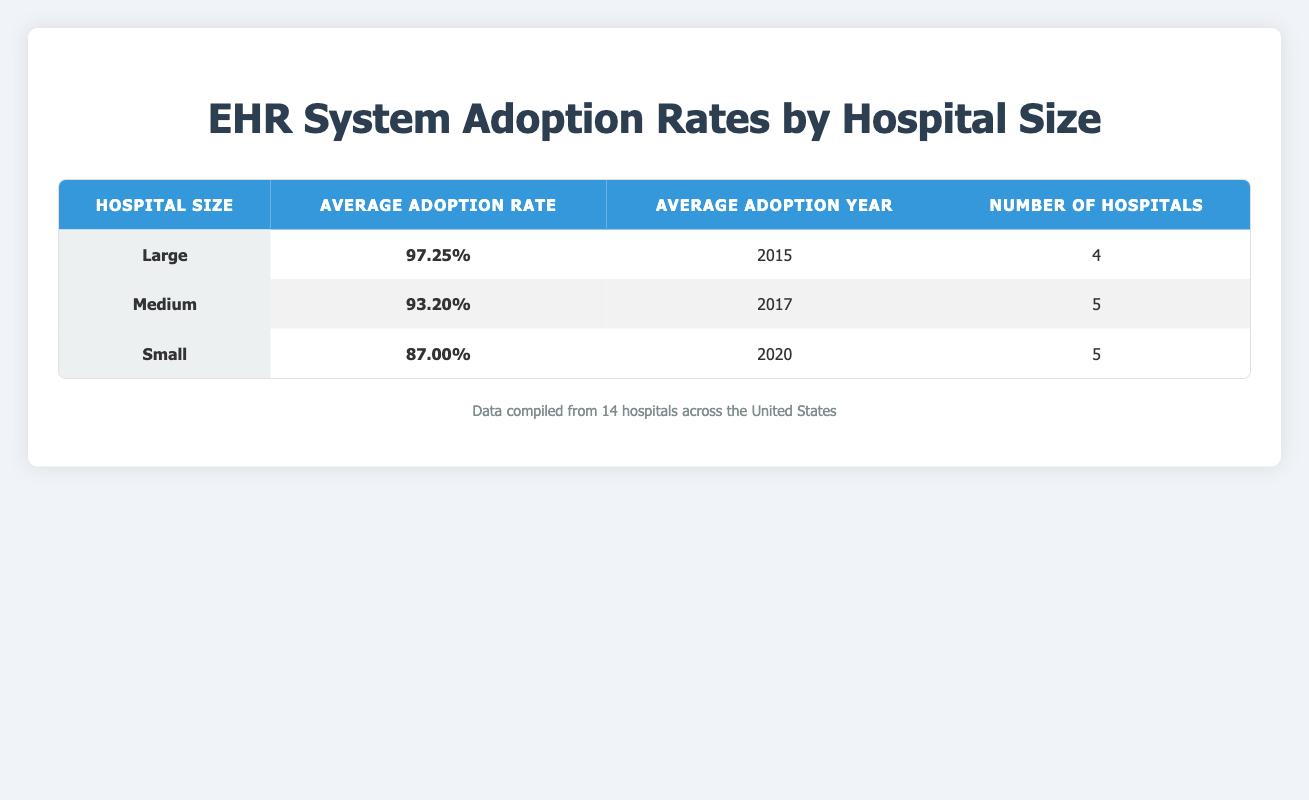What is the average adoption rate for large hospitals? In the table, the average adoption rate for large hospitals is explicitly mentioned as 97.25%.
Answer: 97.25% What is the average adoption year for medium-sized hospitals? The table indicates that the average adoption year for medium-sized hospitals is 2017.
Answer: 2017 How many hospitals have adopted EHR systems in total? The table shows that there are 4 large hospitals, 5 medium hospitals, and 5 small hospitals. Adding these gives 4 + 5 + 5 = 14 hospitals.
Answer: 14 Is the adoption rate for small hospitals higher than 90%? The average adoption rate for small hospitals is stated as 87.00%, which is below 90%.
Answer: No Calculate the difference in average adoption rates between large and small hospitals. The average adoption rate for large hospitals is 97.25% and for small hospitals is 87.00%. The difference is 97.25% - 87.00% = 10.25%.
Answer: 10.25% What percentage of hospitals listed are categorized as large? There are 4 large hospitals out of a total of 14 hospitals. To find the percentage, calculate (4/14) * 100, which is approximately 28.57%.
Answer: 28.57% Which hospital size shows the latest average adoption year? From the table, small hospitals have an average adoption year of 2020, while medium hospitals have 2017, and large hospitals have 2015. Therefore, small hospitals show the latest average adoption year.
Answer: Small If a hospital were to be added that has a 95% adoption rate and is small, how would this affect the average adoption rate for small hospitals? The current average adoption rate for small hospitals is 87.00% with 5 hospitals. Adding a new hospital with a 95% adoption rate would sum the rates: (87.00% * 5 + 95%)/6 = (435 + 95)/6 = 87.50%. The new average would be 87.50%.
Answer: 87.50% What is the average adoption rate of all hospitals regardless of size? To find the average adoption rate of all hospitals, we calculate: (97.25% * 4 + 93.20% * 5 + 87.00% * 5) / 14. This results in an average adoption rate of approximately 92.12%.
Answer: 92.12% 